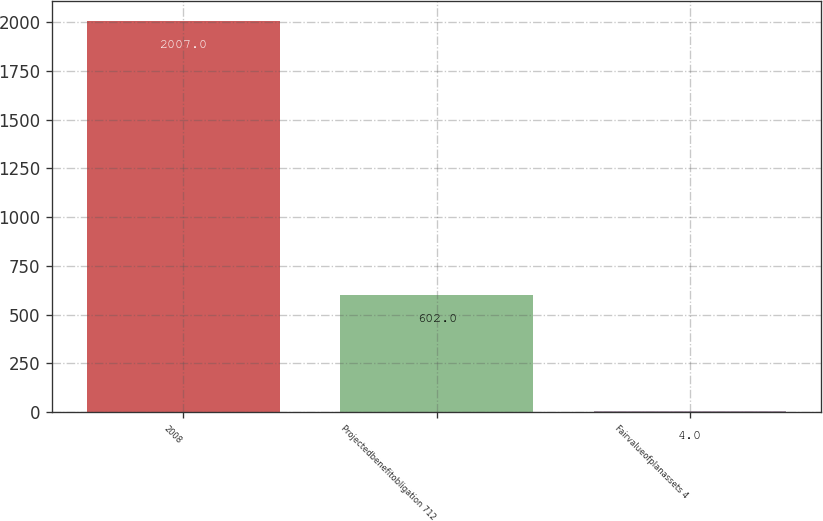<chart> <loc_0><loc_0><loc_500><loc_500><bar_chart><fcel>2008<fcel>Projectedbenefitobligation 712<fcel>Fairvalueofplanassets 4<nl><fcel>2007<fcel>602<fcel>4<nl></chart> 